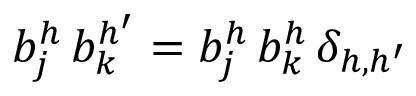<formula> <loc_0><loc_0><loc_500><loc_500>b _ { j } ^ { h } \, b _ { k } ^ { h ^ { \prime } } = b _ { j } ^ { h } \, b _ { k } ^ { h } \, \delta _ { h , h ^ { \prime } }</formula> 